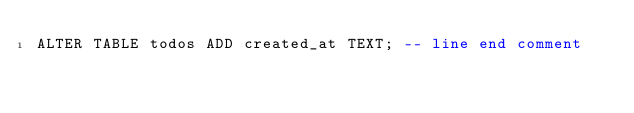<code> <loc_0><loc_0><loc_500><loc_500><_SQL_>ALTER TABLE todos ADD created_at TEXT; -- line end comment</code> 